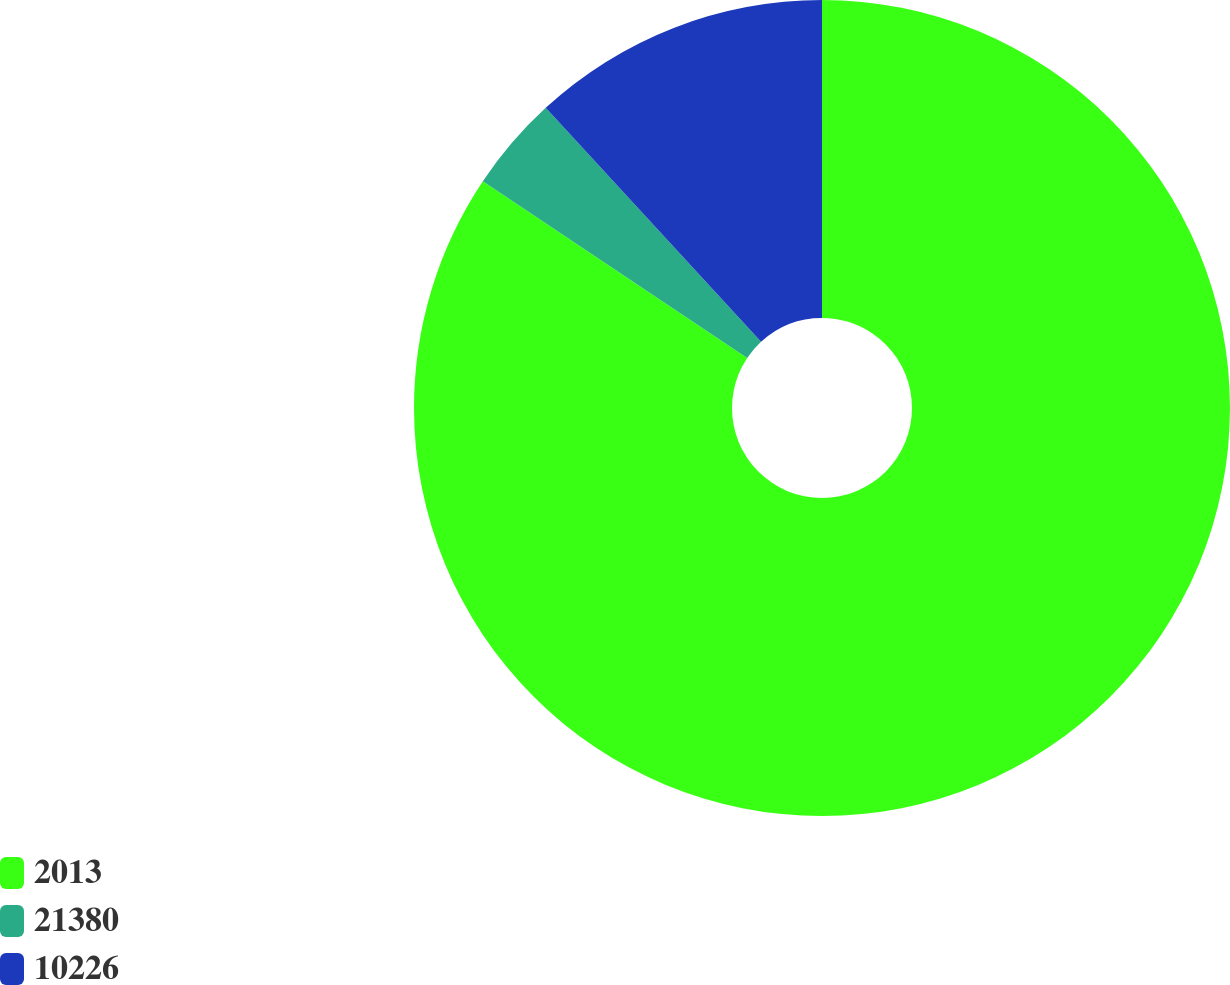Convert chart. <chart><loc_0><loc_0><loc_500><loc_500><pie_chart><fcel>2013<fcel>21380<fcel>10226<nl><fcel>84.38%<fcel>3.78%<fcel>11.84%<nl></chart> 